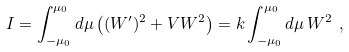Convert formula to latex. <formula><loc_0><loc_0><loc_500><loc_500>I = \int _ { - \mu _ { 0 } } ^ { \mu _ { 0 } } d \mu \left ( ( W ^ { \prime } ) ^ { 2 } + V W ^ { 2 } \right ) = k \int _ { - \mu _ { 0 } } ^ { \mu _ { 0 } } d \mu \, W ^ { 2 } \ ,</formula> 